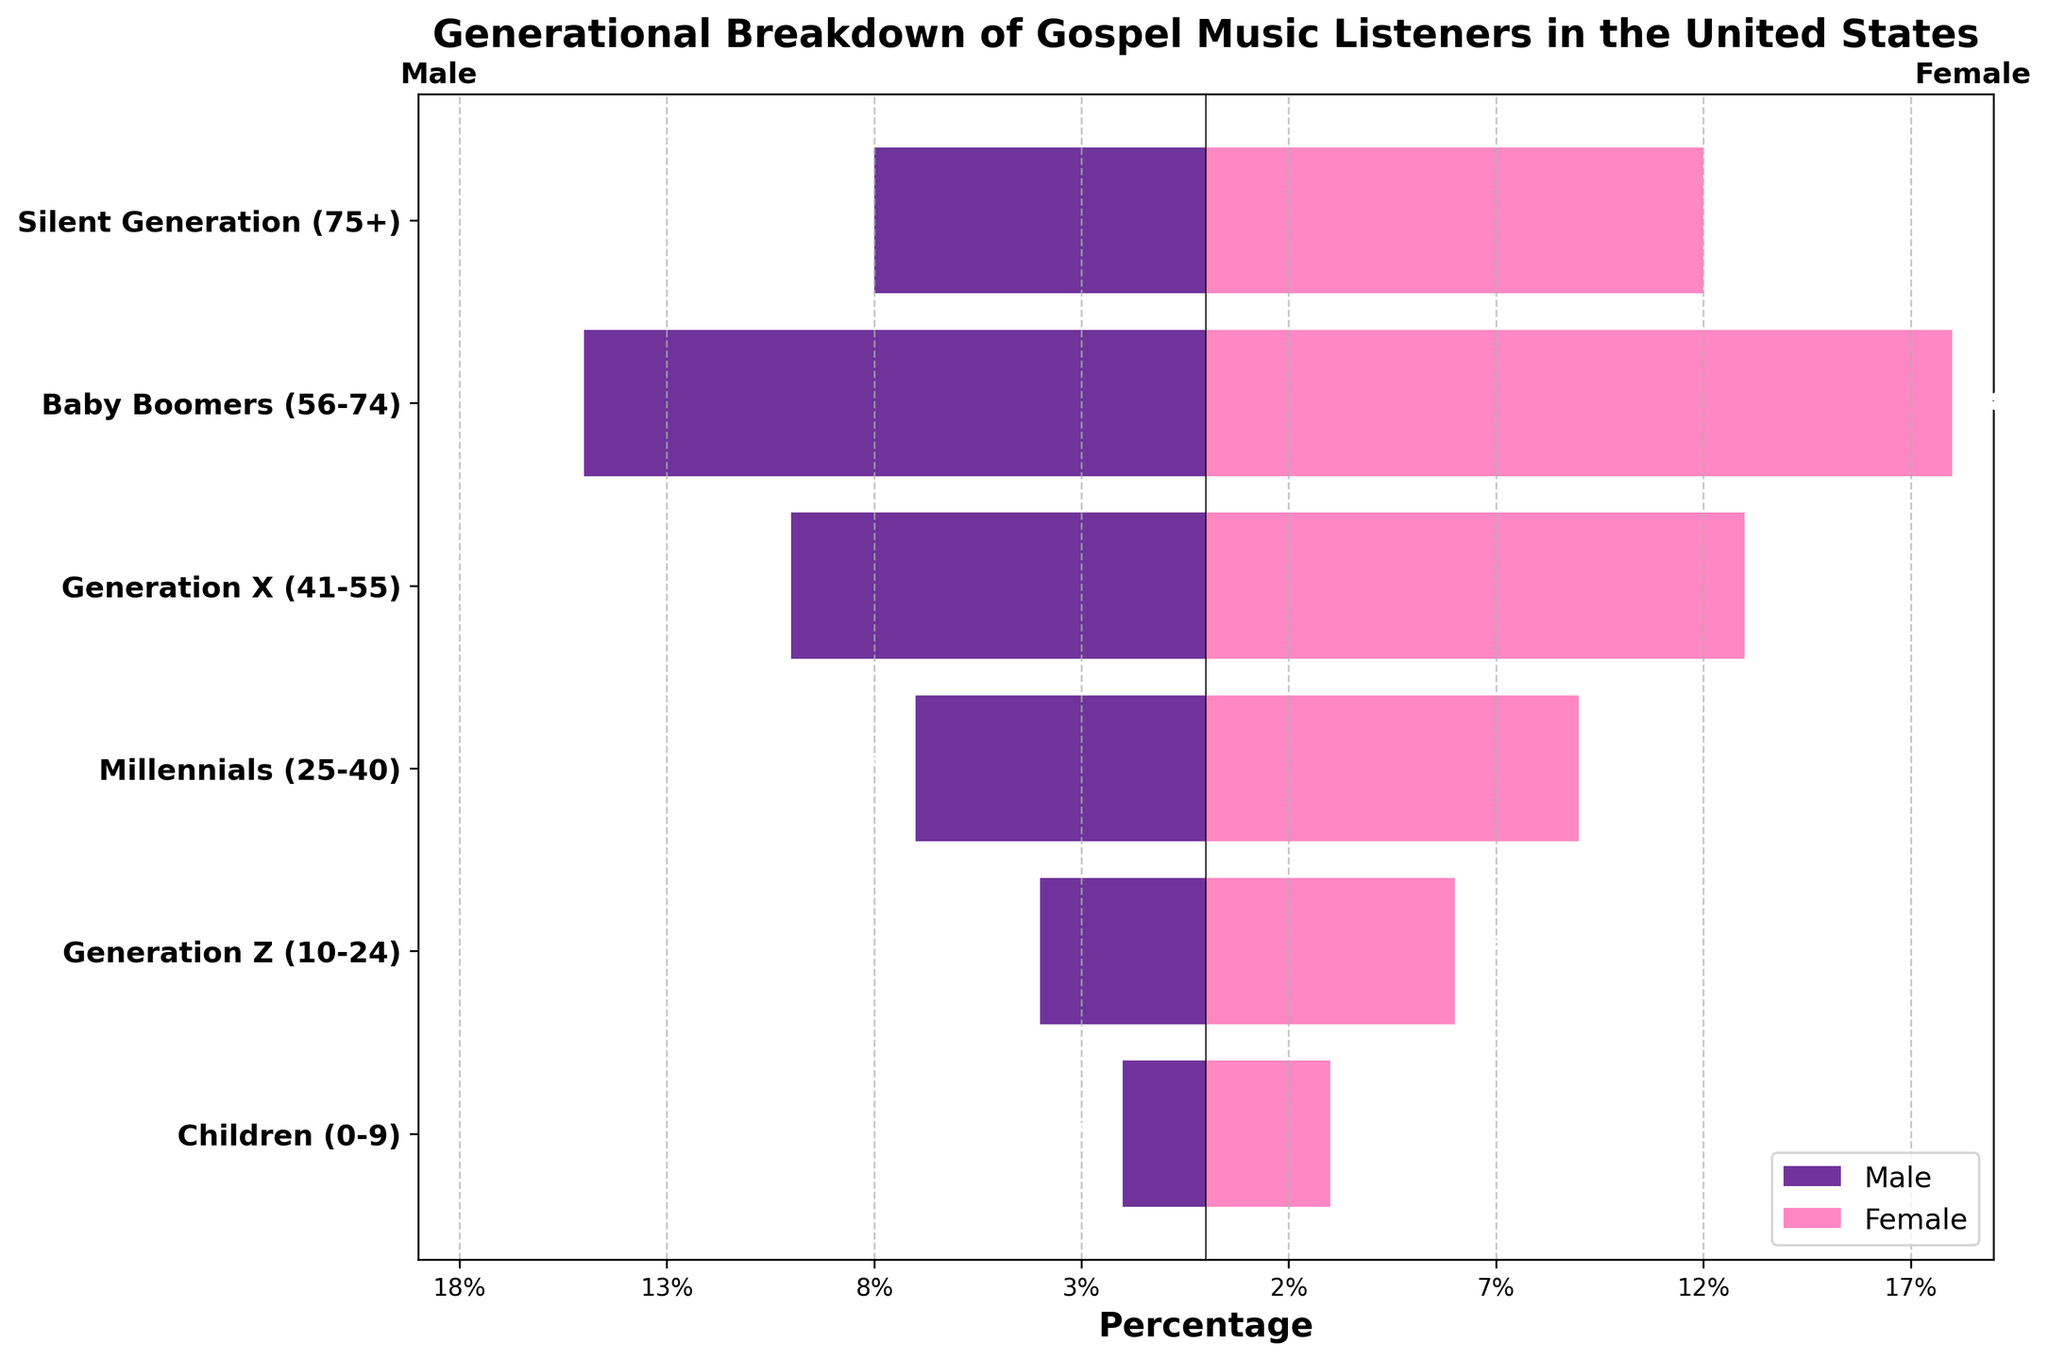what is the title of the figure? The title of the figure is typically positioned at the top and is meant to provide a brief description of the chart's subject matter. According to the code provided, the title of the figure is "Generational Breakdown of Gospel Music Listeners in the United States."
Answer: Generational Breakdown of Gospel Music Listeners in the United States Which age group has the highest percentage of female gospel music listeners? To find the answer, one would compare the height of the bars representing female listeners across all age groups. The tallest bar will indicate the highest percentage. According to the data provided, Baby Boomers (56-74) have the highest percentage of female listeners at 18%.
Answer: Baby Boomers (56-74) How many total male and female listeners are there for Generation X (41-55)? To determine the total number of listeners in Generation X (41-55), you sum the values for both male and female listeners in this category. From the data, there are 10 male and 13 female listeners in this age group. Adding them together, 10 (male) + 13 (female) = 23 total listeners.
Answer: 23 Which gender has a larger percentage of listeners in the Silent Generation (75+)? One needs to compare the absolute values of the bars representing male and female listeners within the Silent Generation (75+) age group. According to the data, there are 8% male and 12% female listeners. Therefore, females have a larger percentage.
Answer: Female What is the total percentage of gospel music listeners in the Baby Boomers and Millennials categories? To find the total percentage, add up the male and female percentages for both age groups. For Baby Boomers (56-74), it's 15% (male) + 18% (female) = 33%. For Millennials (25-40), it's 7% (male) + 9% (female) = 16%. Adding these totals gives 33% + 16% = 49%.
Answer: 49% By how much does the percentage of male listeners in Generation Z differ from the percentage of male listeners in the Silent Generation? Subtract the smaller percentage from the larger percentage within the male listeners for both age groups. For the Silent Generation (75+), the percentage is 8%, and for Generation Z (10-24), it is 4%. The difference is 8% - 4% = 4%.
Answer: 4% Identify the age group with the smallest percentage of male gospel music listeners. Compare the bars representing male listeners across all age groups and identify the smallest one. According to the data, the age group with the smallest percentage of male listeners is Children (0-9) with 2%.
Answer: Children (0-9) What can you say about the gender distribution in the Millennials age group? To analyze the gender distribution within the Millennials (25-40) age group, look at both the male and female bars for this category. According to the data, there are 7% male and 9% female listeners. The percentage of female listeners is higher, indicating a slight predominance of female gospel music listeners in this age group.
Answer: Slightly more female listeners 